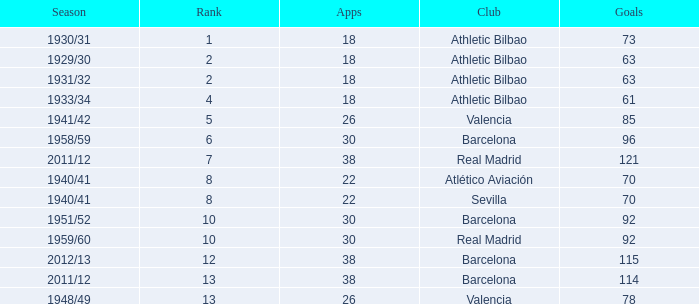Who was the club having less than 22 apps and ranked less than 2? Athletic Bilbao. 